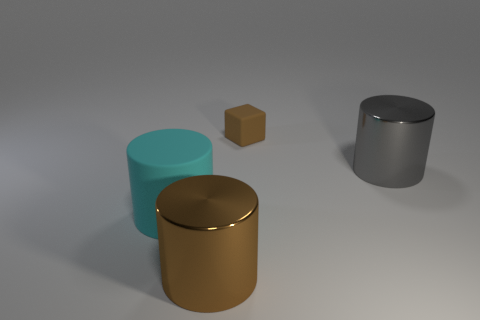There is a large object that is the same color as the small matte object; what is its material?
Provide a succinct answer. Metal. Do the big metallic object that is in front of the large cyan thing and the small rubber thing have the same shape?
Provide a short and direct response. No. How many big rubber cylinders are the same color as the small object?
Offer a very short reply. 0. Are there fewer gray objects that are in front of the gray metallic thing than large cyan cylinders that are left of the large brown metal cylinder?
Make the answer very short. Yes. What is the size of the brown thing behind the gray metallic object?
Give a very brief answer. Small. Is there a gray thing made of the same material as the large brown thing?
Your answer should be very brief. Yes. Is the material of the large brown object the same as the large gray cylinder?
Give a very brief answer. Yes. What is the color of the rubber thing that is the same size as the brown cylinder?
Provide a succinct answer. Cyan. How many other things are there of the same shape as the tiny matte object?
Keep it short and to the point. 0. There is a brown cylinder; is it the same size as the thing on the right side of the brown block?
Offer a terse response. Yes. 